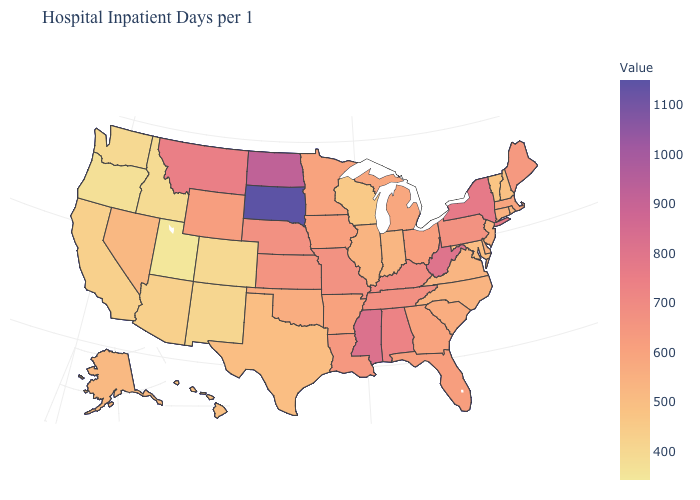Does West Virginia have a lower value than South Dakota?
Answer briefly. Yes. Among the states that border Alabama , which have the highest value?
Quick response, please. Mississippi. Which states hav the highest value in the Northeast?
Answer briefly. New York. Does California have the highest value in the West?
Give a very brief answer. No. Among the states that border Connecticut , which have the highest value?
Write a very short answer. New York. Which states have the lowest value in the Northeast?
Keep it brief. Vermont. Is the legend a continuous bar?
Give a very brief answer. Yes. Which states have the lowest value in the USA?
Quick response, please. Utah. Among the states that border New Jersey , does Pennsylvania have the lowest value?
Quick response, please. No. 